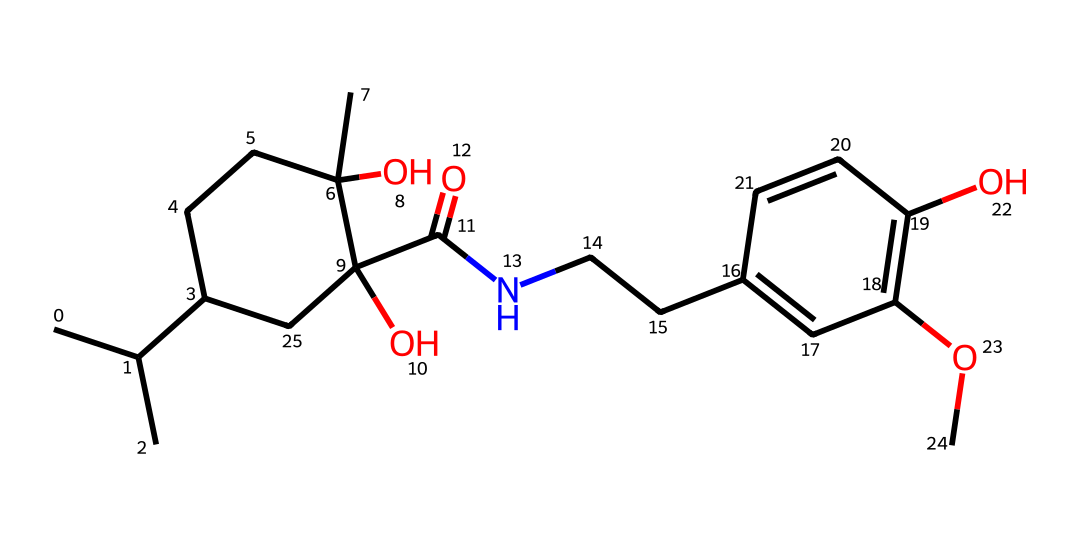What is the molecular formula of this compound? By analyzing the SMILES representation, we can deduce the molecular formula by counting the number of each atom present. The SMILES indicates the presence of multiple carbon (C), hydrogen (H), oxygen (O), and nitrogen (N) atoms, leading to the final count of 27 carbons, 41 hydrogens, 5 oxygens, and 1 nitrogen.
Answer: C27H41N5O5 How many chiral centers are in this molecule? A chiral center is typically represented by a carbon atom bonded to four different substituents. By examining the structure represented by the SMILES, I identify the carbon atoms that fulfill this criterion. There are a total of 4 such carbons in the structure that can be classified as chiral centers.
Answer: 4 What type of compound is this according to its functional groups? The SMILES indicates the presence of multiple functional groups, specifically hydroxyl (-OH) groups and an amide (C(=O)N) group. The combination of these functional groups suggests that the compound can be classified as an alcohol and an amide.
Answer: alcohol and amide What characteristic makes this molecule chiral? Chirality in molecules is characterized by the presence of non-superimposable mirror images, which is a result of having chiral centers. In this molecule, the chiral centers possess different substituents around the carbon atoms, allowing for isomerism. Thus, the non-superimposable nature of the four chiral centers confirms its chirality.
Answer: chiral centers Is this compound likely to be hydrophilic or hydrophobic? The presence of multiple hydroxyl (-OH) groups in the structure typically increases the hydrophilicity of a compound due to the potential for hydrogen bonding with water. As a result, considering the number of polar functional groups, this compound is likely to be hydrophilic.
Answer: hydrophilic 